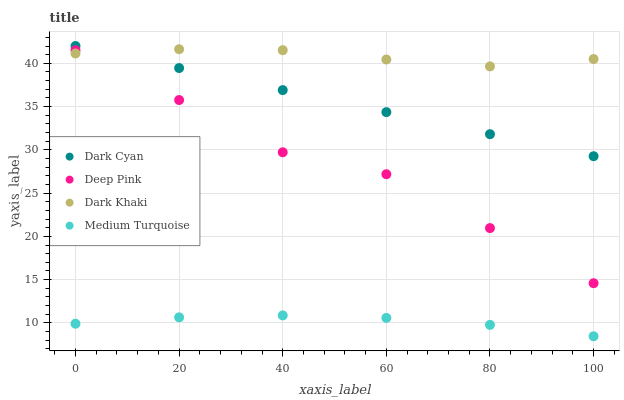Does Medium Turquoise have the minimum area under the curve?
Answer yes or no. Yes. Does Dark Khaki have the maximum area under the curve?
Answer yes or no. Yes. Does Deep Pink have the minimum area under the curve?
Answer yes or no. No. Does Deep Pink have the maximum area under the curve?
Answer yes or no. No. Is Dark Cyan the smoothest?
Answer yes or no. Yes. Is Deep Pink the roughest?
Answer yes or no. Yes. Is Dark Khaki the smoothest?
Answer yes or no. No. Is Dark Khaki the roughest?
Answer yes or no. No. Does Medium Turquoise have the lowest value?
Answer yes or no. Yes. Does Deep Pink have the lowest value?
Answer yes or no. No. Does Dark Cyan have the highest value?
Answer yes or no. Yes. Does Dark Khaki have the highest value?
Answer yes or no. No. Is Medium Turquoise less than Dark Khaki?
Answer yes or no. Yes. Is Dark Cyan greater than Medium Turquoise?
Answer yes or no. Yes. Does Deep Pink intersect Dark Khaki?
Answer yes or no. Yes. Is Deep Pink less than Dark Khaki?
Answer yes or no. No. Is Deep Pink greater than Dark Khaki?
Answer yes or no. No. Does Medium Turquoise intersect Dark Khaki?
Answer yes or no. No. 